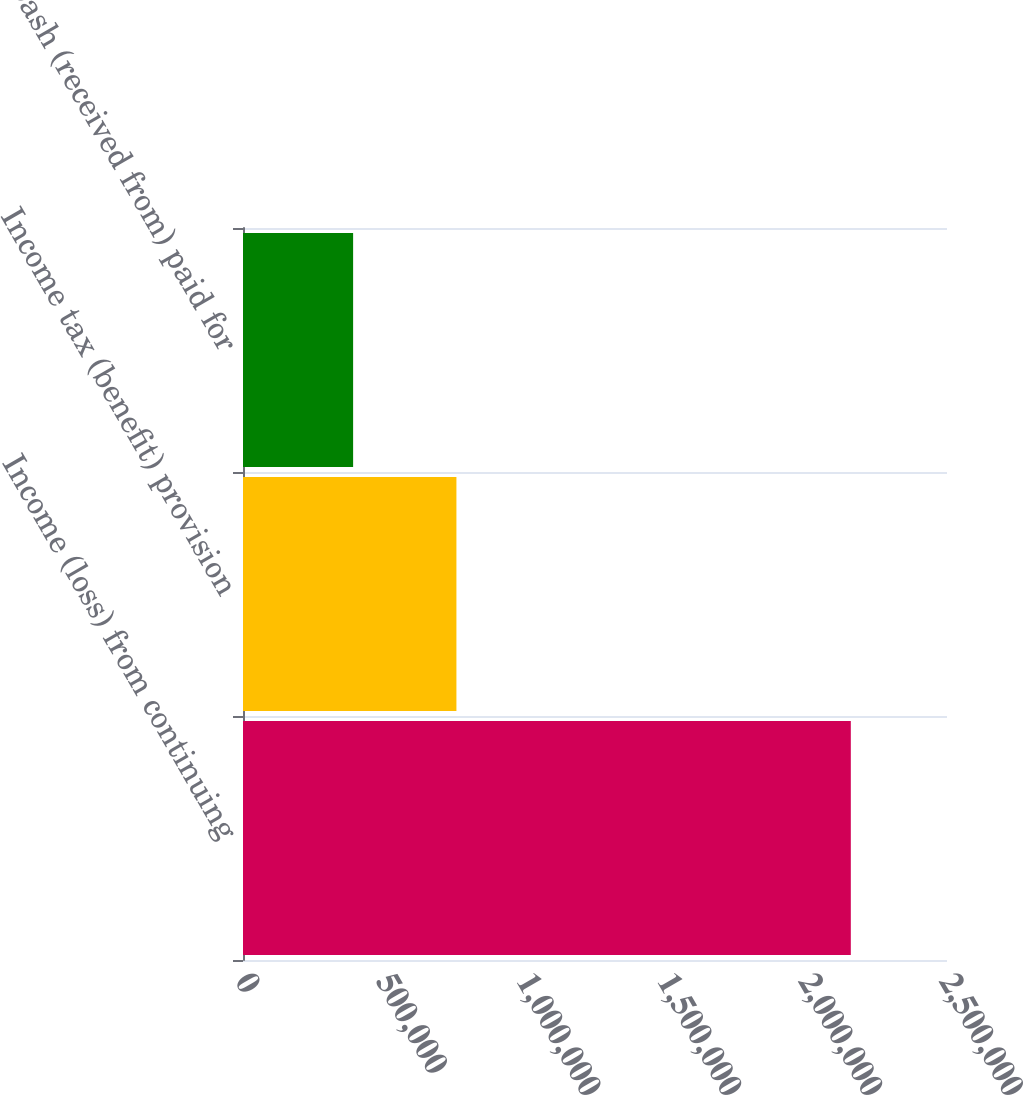Convert chart. <chart><loc_0><loc_0><loc_500><loc_500><bar_chart><fcel>Income (loss) from continuing<fcel>Income tax (benefit) provision<fcel>Cash (received from) paid for<nl><fcel>2.15843e+06<fcel>757883<fcel>391042<nl></chart> 